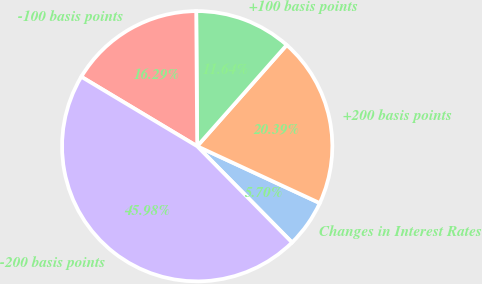<chart> <loc_0><loc_0><loc_500><loc_500><pie_chart><fcel>Changes in Interest Rates<fcel>+200 basis points<fcel>+100 basis points<fcel>-100 basis points<fcel>-200 basis points<nl><fcel>5.7%<fcel>20.39%<fcel>11.64%<fcel>16.29%<fcel>45.98%<nl></chart> 